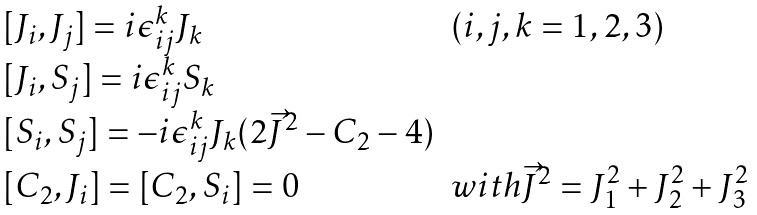<formula> <loc_0><loc_0><loc_500><loc_500>\begin{array} { l l } { [ } J _ { i } , J _ { j } ] = i \epsilon _ { i j } ^ { k } J _ { k } & ( i , j , k = 1 , 2 , 3 ) \\ { [ } J _ { i } , S _ { j } ] = i \epsilon _ { i j } ^ { k } S _ { k } & \\ { [ } S _ { i } , S _ { j } ] = - i \epsilon _ { i j } ^ { k } J _ { k } ( 2 \vec { J } ^ { 2 } - C _ { 2 } - 4 ) & \\ { [ } C _ { 2 } , J _ { i } ] = [ C _ { 2 } , S _ { i } ] = 0 & w i t h \vec { J } ^ { 2 } = J ^ { 2 } _ { 1 } + J ^ { 2 } _ { 2 } + J _ { 3 } ^ { 2 } \end{array}</formula> 